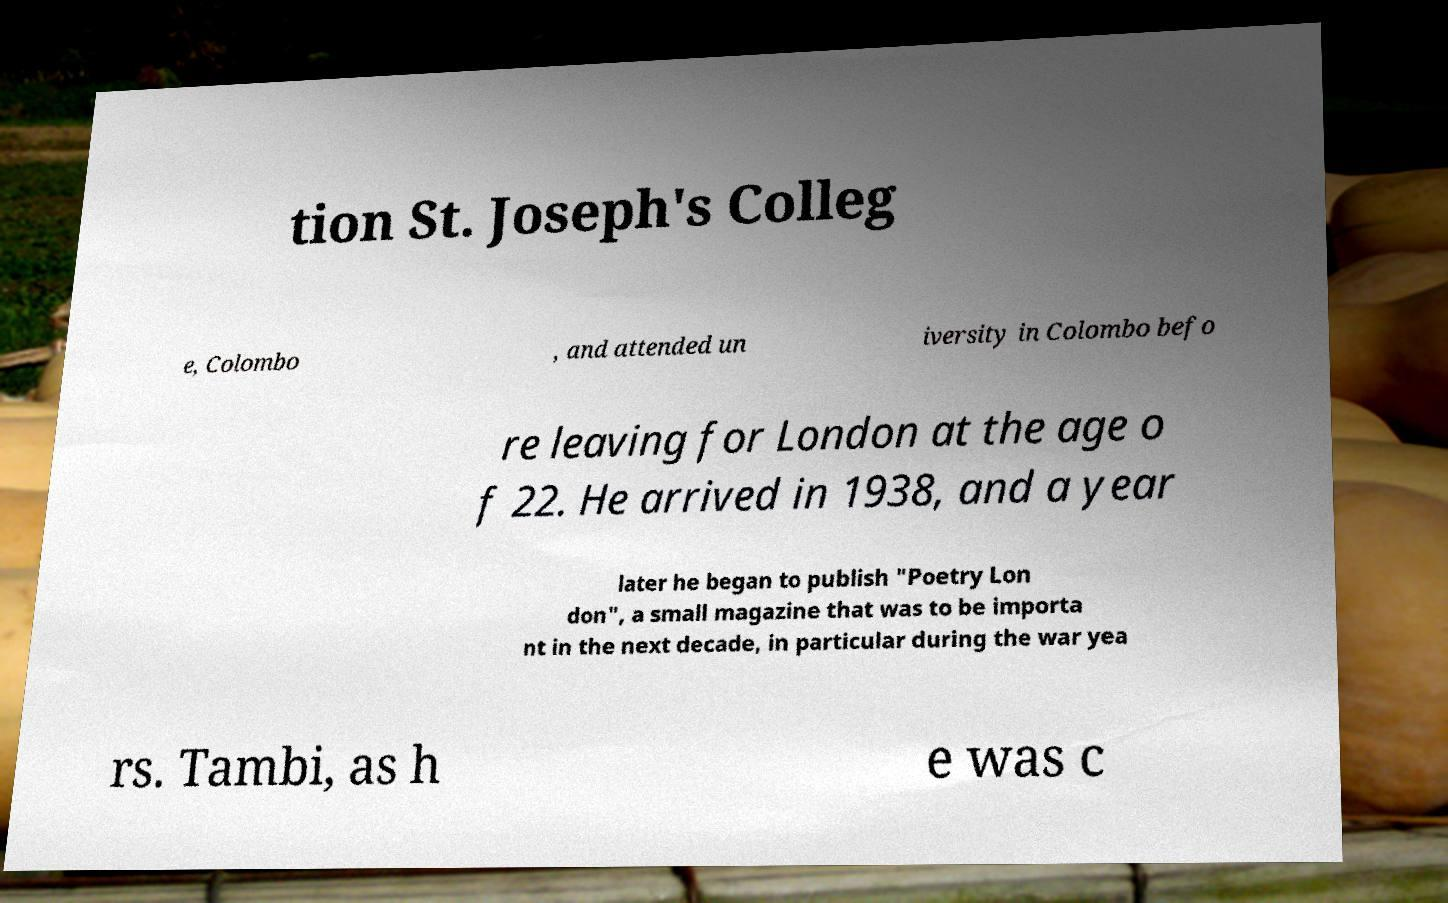What messages or text are displayed in this image? I need them in a readable, typed format. tion St. Joseph's Colleg e, Colombo , and attended un iversity in Colombo befo re leaving for London at the age o f 22. He arrived in 1938, and a year later he began to publish "Poetry Lon don", a small magazine that was to be importa nt in the next decade, in particular during the war yea rs. Tambi, as h e was c 